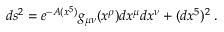<formula> <loc_0><loc_0><loc_500><loc_500>d s ^ { 2 } = e ^ { - A ( x ^ { 5 } ) } g _ { \mu \nu } ( x ^ { \rho } ) d x ^ { \mu } d x ^ { \nu } + ( d x ^ { 5 } ) ^ { 2 } \, .</formula> 